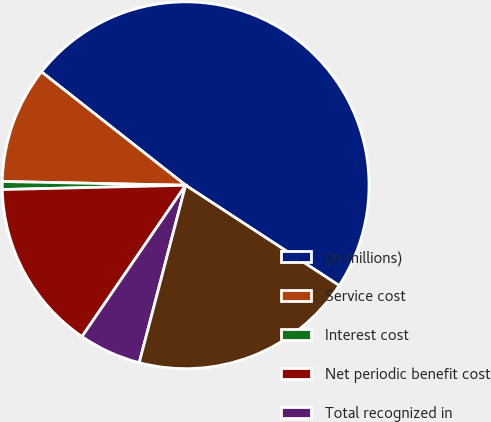<chart> <loc_0><loc_0><loc_500><loc_500><pie_chart><fcel>(in millions)<fcel>Service cost<fcel>Interest cost<fcel>Net periodic benefit cost<fcel>Total recognized in<fcel>Total recognized in net<nl><fcel>48.6%<fcel>10.28%<fcel>0.7%<fcel>15.07%<fcel>5.49%<fcel>19.86%<nl></chart> 